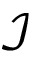<formula> <loc_0><loc_0><loc_500><loc_500>\mathcal { I }</formula> 